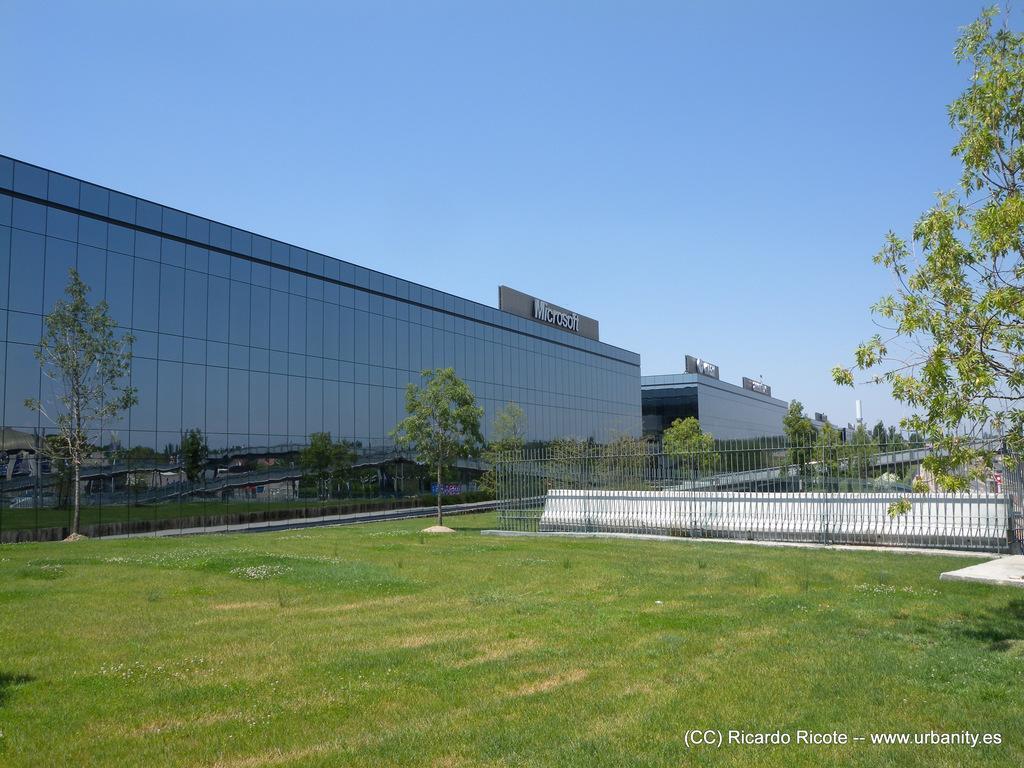In one or two sentences, can you explain what this image depicts? In this image I can see the ground. To the side there is a railing. In the back there are many trees. I can also see the building and the sky which is in blue color. 